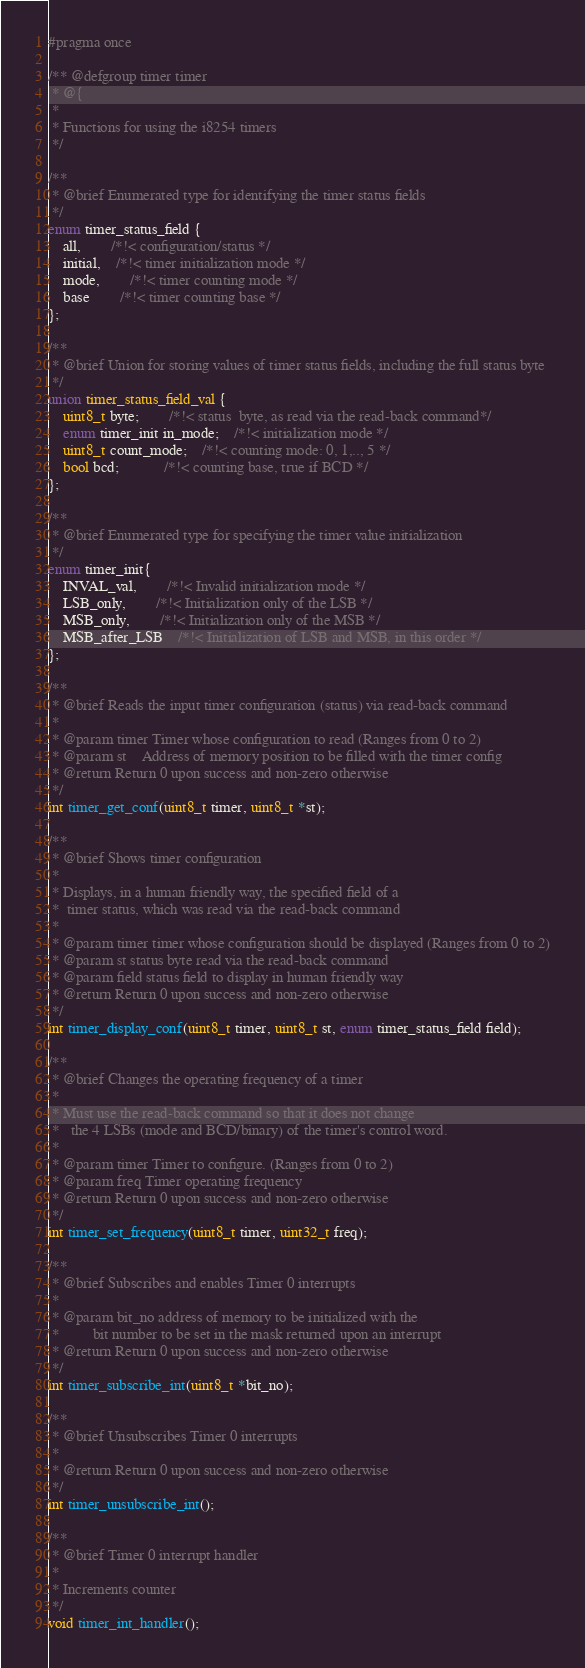Convert code to text. <code><loc_0><loc_0><loc_500><loc_500><_C_>#pragma once

/** @defgroup timer timer
 * @{
 *
 * Functions for using the i8254 timers
 */

/**
 * @brief Enumerated type for identifying the timer status fields
 */
enum timer_status_field {
	all,		/*!< configuration/status */
	initial,	/*!< timer initialization mode */
	mode,		/*!< timer counting mode */
	base		/*!< timer counting base */
};

/**
 * @brief Union for storing values of timer status fields, including the full status byte
 */
union timer_status_field_val {
	uint8_t byte;		/*!< status  byte, as read via the read-back command*/
	enum timer_init in_mode;	/*!< initialization mode */
	uint8_t count_mode;	/*!< counting mode: 0, 1,.., 5 */
	bool bcd;			/*!< counting base, true if BCD */
};

/**
 * @brief Enumerated type for specifying the timer value initialization
 */
enum timer_init{
	INVAL_val, 		/*!< Invalid initialization mode */
	LSB_only,		/*!< Initialization only of the LSB */
	MSB_only,		/*!< Initialization only of the MSB */
	MSB_after_LSB	/*!< Initialization of LSB and MSB, in this order */
};

/**
 * @brief Reads the input timer configuration (status) via read-back command
 *
 * @param timer Timer whose configuration to read (Ranges from 0 to 2)
 * @param st    Address of memory position to be filled with the timer config
 * @return Return 0 upon success and non-zero otherwise
 */
int timer_get_conf(uint8_t timer, uint8_t *st);

/**
 * @brief Shows timer configuration
 *
 * Displays, in a human friendly way, the specified field of a
 *  timer status, which was read via the read-back command
 *
 * @param timer timer whose configuration should be displayed (Ranges from 0 to 2)
 * @param st status byte read via the read-back command
 * @param field status field to display in human friendly way
 * @return Return 0 upon success and non-zero otherwise
 */
int timer_display_conf(uint8_t timer, uint8_t st, enum timer_status_field field);

/**
 * @brief Changes the operating frequency of a timer
 *
 * Must use the read-back command so that it does not change
 *   the 4 LSBs (mode and BCD/binary) of the timer's control word.
 *
 * @param timer Timer to configure. (Ranges from 0 to 2)
 * @param freq Timer operating frequency
 * @return Return 0 upon success and non-zero otherwise
 */
int timer_set_frequency(uint8_t timer, uint32_t freq);

/**
 * @brief Subscribes and enables Timer 0 interrupts
 *
 * @param bit_no address of memory to be initialized with the
 *         bit number to be set in the mask returned upon an interrupt
 * @return Return 0 upon success and non-zero otherwise
 */
int timer_subscribe_int(uint8_t *bit_no);

/**
 * @brief Unsubscribes Timer 0 interrupts
 *
 * @return Return 0 upon success and non-zero otherwise
 */
int timer_unsubscribe_int();

/**
 * @brief Timer 0 interrupt handler
 *
 * Increments counter
 */
void timer_int_handler();
</code> 